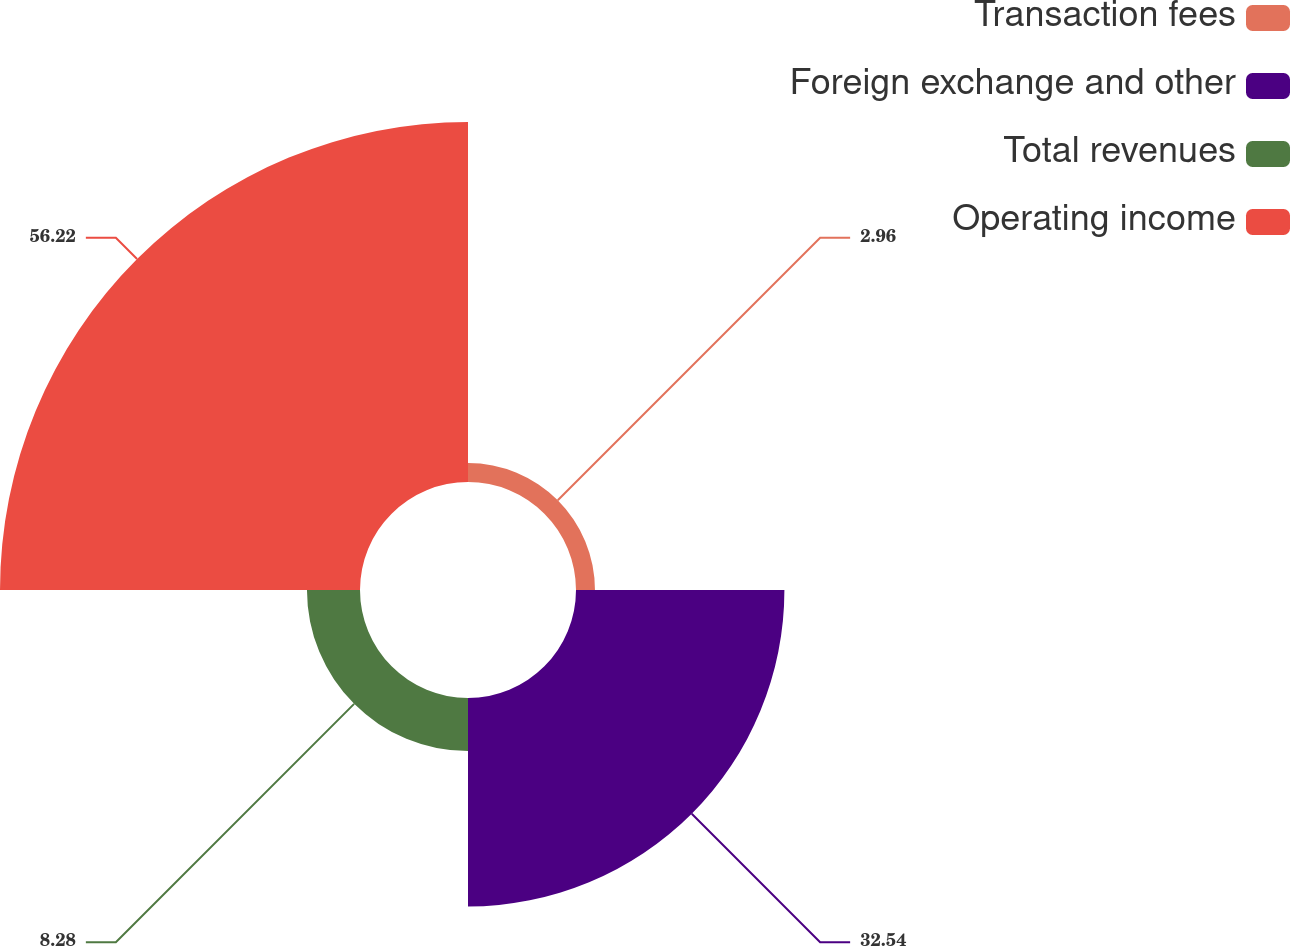<chart> <loc_0><loc_0><loc_500><loc_500><pie_chart><fcel>Transaction fees<fcel>Foreign exchange and other<fcel>Total revenues<fcel>Operating income<nl><fcel>2.96%<fcel>32.54%<fcel>8.28%<fcel>56.21%<nl></chart> 